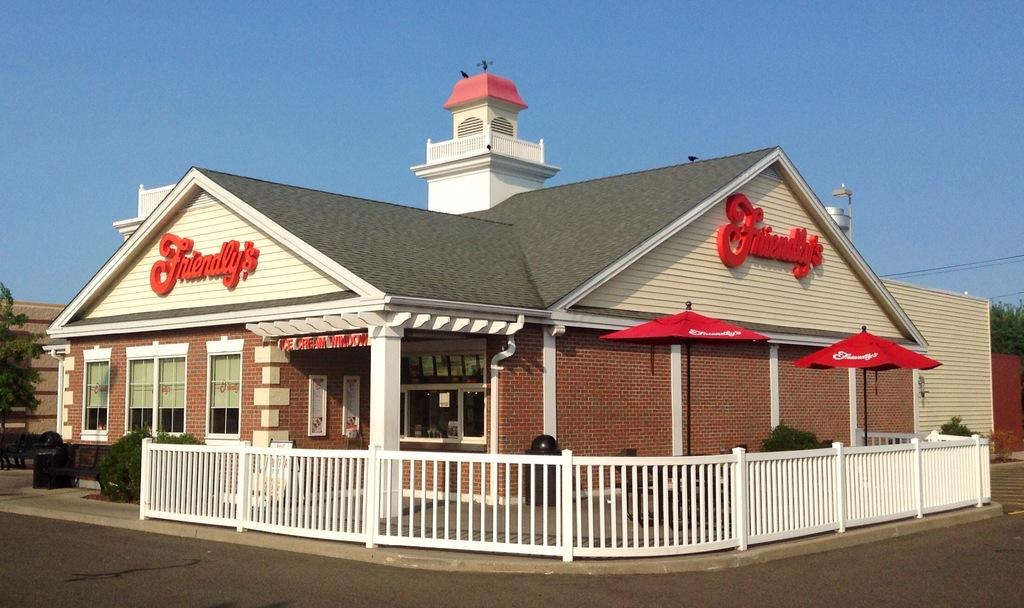What is the name of the restaurant?
Provide a short and direct response. Friendly's. Time to eat?
Ensure brevity in your answer.  Yes. 